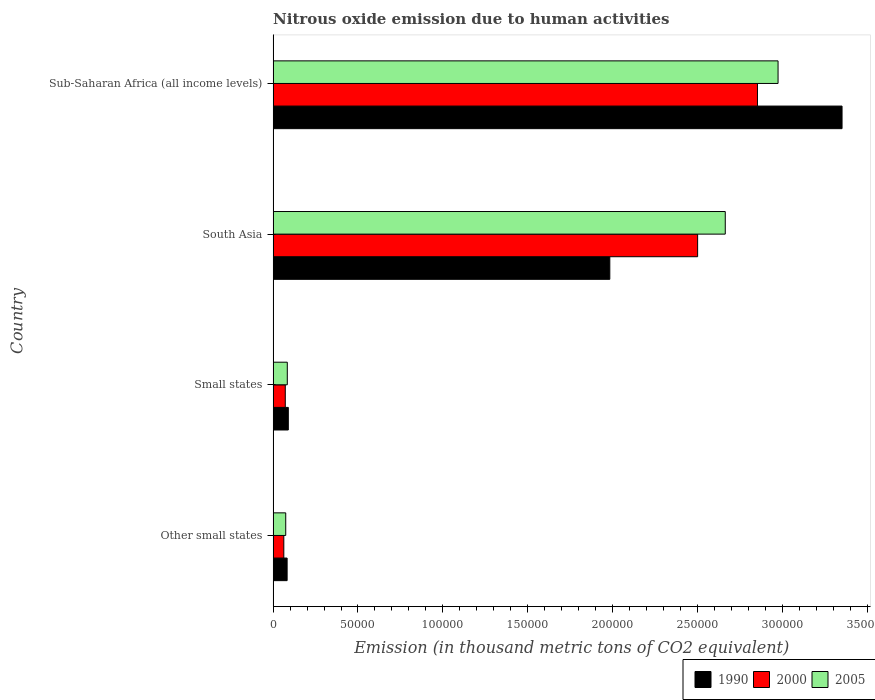How many groups of bars are there?
Offer a terse response. 4. Are the number of bars on each tick of the Y-axis equal?
Provide a succinct answer. Yes. How many bars are there on the 1st tick from the top?
Your answer should be compact. 3. What is the label of the 3rd group of bars from the top?
Offer a very short reply. Small states. What is the amount of nitrous oxide emitted in 1990 in Sub-Saharan Africa (all income levels)?
Give a very brief answer. 3.35e+05. Across all countries, what is the maximum amount of nitrous oxide emitted in 2000?
Give a very brief answer. 2.85e+05. Across all countries, what is the minimum amount of nitrous oxide emitted in 1990?
Provide a succinct answer. 8248.7. In which country was the amount of nitrous oxide emitted in 1990 maximum?
Provide a succinct answer. Sub-Saharan Africa (all income levels). In which country was the amount of nitrous oxide emitted in 2005 minimum?
Your answer should be compact. Other small states. What is the total amount of nitrous oxide emitted in 2000 in the graph?
Make the answer very short. 5.49e+05. What is the difference between the amount of nitrous oxide emitted in 2005 in Small states and that in Sub-Saharan Africa (all income levels)?
Make the answer very short. -2.89e+05. What is the difference between the amount of nitrous oxide emitted in 2005 in Other small states and the amount of nitrous oxide emitted in 1990 in South Asia?
Make the answer very short. -1.91e+05. What is the average amount of nitrous oxide emitted in 2005 per country?
Your answer should be compact. 1.45e+05. What is the difference between the amount of nitrous oxide emitted in 1990 and amount of nitrous oxide emitted in 2000 in Other small states?
Provide a succinct answer. 1951.7. What is the ratio of the amount of nitrous oxide emitted in 2005 in Other small states to that in Sub-Saharan Africa (all income levels)?
Make the answer very short. 0.02. Is the amount of nitrous oxide emitted in 2005 in Other small states less than that in Small states?
Provide a short and direct response. Yes. Is the difference between the amount of nitrous oxide emitted in 1990 in Other small states and South Asia greater than the difference between the amount of nitrous oxide emitted in 2000 in Other small states and South Asia?
Provide a short and direct response. Yes. What is the difference between the highest and the second highest amount of nitrous oxide emitted in 2005?
Provide a short and direct response. 3.11e+04. What is the difference between the highest and the lowest amount of nitrous oxide emitted in 2005?
Give a very brief answer. 2.90e+05. Is the sum of the amount of nitrous oxide emitted in 2000 in South Asia and Sub-Saharan Africa (all income levels) greater than the maximum amount of nitrous oxide emitted in 2005 across all countries?
Offer a very short reply. Yes. What does the 3rd bar from the top in Other small states represents?
Ensure brevity in your answer.  1990. What does the 1st bar from the bottom in Other small states represents?
Offer a very short reply. 1990. How many bars are there?
Your answer should be very brief. 12. How many countries are there in the graph?
Your answer should be very brief. 4. Does the graph contain grids?
Provide a succinct answer. No. How many legend labels are there?
Your answer should be compact. 3. How are the legend labels stacked?
Ensure brevity in your answer.  Horizontal. What is the title of the graph?
Your response must be concise. Nitrous oxide emission due to human activities. Does "1984" appear as one of the legend labels in the graph?
Give a very brief answer. No. What is the label or title of the X-axis?
Your response must be concise. Emission (in thousand metric tons of CO2 equivalent). What is the Emission (in thousand metric tons of CO2 equivalent) in 1990 in Other small states?
Your response must be concise. 8248.7. What is the Emission (in thousand metric tons of CO2 equivalent) in 2000 in Other small states?
Your response must be concise. 6297. What is the Emission (in thousand metric tons of CO2 equivalent) in 2005 in Other small states?
Ensure brevity in your answer.  7434.8. What is the Emission (in thousand metric tons of CO2 equivalent) in 1990 in Small states?
Ensure brevity in your answer.  8947.8. What is the Emission (in thousand metric tons of CO2 equivalent) of 2000 in Small states?
Make the answer very short. 7164.7. What is the Emission (in thousand metric tons of CO2 equivalent) of 2005 in Small states?
Keep it short and to the point. 8358.1. What is the Emission (in thousand metric tons of CO2 equivalent) of 1990 in South Asia?
Offer a terse response. 1.98e+05. What is the Emission (in thousand metric tons of CO2 equivalent) of 2000 in South Asia?
Make the answer very short. 2.50e+05. What is the Emission (in thousand metric tons of CO2 equivalent) of 2005 in South Asia?
Make the answer very short. 2.66e+05. What is the Emission (in thousand metric tons of CO2 equivalent) of 1990 in Sub-Saharan Africa (all income levels)?
Ensure brevity in your answer.  3.35e+05. What is the Emission (in thousand metric tons of CO2 equivalent) in 2000 in Sub-Saharan Africa (all income levels)?
Offer a terse response. 2.85e+05. What is the Emission (in thousand metric tons of CO2 equivalent) in 2005 in Sub-Saharan Africa (all income levels)?
Provide a succinct answer. 2.98e+05. Across all countries, what is the maximum Emission (in thousand metric tons of CO2 equivalent) in 1990?
Provide a short and direct response. 3.35e+05. Across all countries, what is the maximum Emission (in thousand metric tons of CO2 equivalent) of 2000?
Keep it short and to the point. 2.85e+05. Across all countries, what is the maximum Emission (in thousand metric tons of CO2 equivalent) in 2005?
Your answer should be very brief. 2.98e+05. Across all countries, what is the minimum Emission (in thousand metric tons of CO2 equivalent) in 1990?
Provide a succinct answer. 8248.7. Across all countries, what is the minimum Emission (in thousand metric tons of CO2 equivalent) of 2000?
Keep it short and to the point. 6297. Across all countries, what is the minimum Emission (in thousand metric tons of CO2 equivalent) in 2005?
Offer a very short reply. 7434.8. What is the total Emission (in thousand metric tons of CO2 equivalent) of 1990 in the graph?
Offer a terse response. 5.51e+05. What is the total Emission (in thousand metric tons of CO2 equivalent) of 2000 in the graph?
Your answer should be compact. 5.49e+05. What is the total Emission (in thousand metric tons of CO2 equivalent) of 2005 in the graph?
Make the answer very short. 5.80e+05. What is the difference between the Emission (in thousand metric tons of CO2 equivalent) in 1990 in Other small states and that in Small states?
Keep it short and to the point. -699.1. What is the difference between the Emission (in thousand metric tons of CO2 equivalent) in 2000 in Other small states and that in Small states?
Your answer should be very brief. -867.7. What is the difference between the Emission (in thousand metric tons of CO2 equivalent) in 2005 in Other small states and that in Small states?
Keep it short and to the point. -923.3. What is the difference between the Emission (in thousand metric tons of CO2 equivalent) of 1990 in Other small states and that in South Asia?
Give a very brief answer. -1.90e+05. What is the difference between the Emission (in thousand metric tons of CO2 equivalent) in 2000 in Other small states and that in South Asia?
Your answer should be very brief. -2.44e+05. What is the difference between the Emission (in thousand metric tons of CO2 equivalent) in 2005 in Other small states and that in South Asia?
Keep it short and to the point. -2.59e+05. What is the difference between the Emission (in thousand metric tons of CO2 equivalent) of 1990 in Other small states and that in Sub-Saharan Africa (all income levels)?
Your response must be concise. -3.27e+05. What is the difference between the Emission (in thousand metric tons of CO2 equivalent) of 2000 in Other small states and that in Sub-Saharan Africa (all income levels)?
Provide a short and direct response. -2.79e+05. What is the difference between the Emission (in thousand metric tons of CO2 equivalent) in 2005 in Other small states and that in Sub-Saharan Africa (all income levels)?
Your response must be concise. -2.90e+05. What is the difference between the Emission (in thousand metric tons of CO2 equivalent) of 1990 in Small states and that in South Asia?
Provide a short and direct response. -1.89e+05. What is the difference between the Emission (in thousand metric tons of CO2 equivalent) in 2000 in Small states and that in South Asia?
Provide a succinct answer. -2.43e+05. What is the difference between the Emission (in thousand metric tons of CO2 equivalent) in 2005 in Small states and that in South Asia?
Your answer should be very brief. -2.58e+05. What is the difference between the Emission (in thousand metric tons of CO2 equivalent) in 1990 in Small states and that in Sub-Saharan Africa (all income levels)?
Provide a short and direct response. -3.26e+05. What is the difference between the Emission (in thousand metric tons of CO2 equivalent) of 2000 in Small states and that in Sub-Saharan Africa (all income levels)?
Your answer should be very brief. -2.78e+05. What is the difference between the Emission (in thousand metric tons of CO2 equivalent) of 2005 in Small states and that in Sub-Saharan Africa (all income levels)?
Your response must be concise. -2.89e+05. What is the difference between the Emission (in thousand metric tons of CO2 equivalent) of 1990 in South Asia and that in Sub-Saharan Africa (all income levels)?
Offer a very short reply. -1.37e+05. What is the difference between the Emission (in thousand metric tons of CO2 equivalent) of 2000 in South Asia and that in Sub-Saharan Africa (all income levels)?
Your answer should be compact. -3.53e+04. What is the difference between the Emission (in thousand metric tons of CO2 equivalent) of 2005 in South Asia and that in Sub-Saharan Africa (all income levels)?
Keep it short and to the point. -3.11e+04. What is the difference between the Emission (in thousand metric tons of CO2 equivalent) in 1990 in Other small states and the Emission (in thousand metric tons of CO2 equivalent) in 2000 in Small states?
Offer a very short reply. 1084. What is the difference between the Emission (in thousand metric tons of CO2 equivalent) of 1990 in Other small states and the Emission (in thousand metric tons of CO2 equivalent) of 2005 in Small states?
Provide a succinct answer. -109.4. What is the difference between the Emission (in thousand metric tons of CO2 equivalent) of 2000 in Other small states and the Emission (in thousand metric tons of CO2 equivalent) of 2005 in Small states?
Provide a succinct answer. -2061.1. What is the difference between the Emission (in thousand metric tons of CO2 equivalent) of 1990 in Other small states and the Emission (in thousand metric tons of CO2 equivalent) of 2000 in South Asia?
Offer a very short reply. -2.42e+05. What is the difference between the Emission (in thousand metric tons of CO2 equivalent) in 1990 in Other small states and the Emission (in thousand metric tons of CO2 equivalent) in 2005 in South Asia?
Keep it short and to the point. -2.58e+05. What is the difference between the Emission (in thousand metric tons of CO2 equivalent) in 2000 in Other small states and the Emission (in thousand metric tons of CO2 equivalent) in 2005 in South Asia?
Keep it short and to the point. -2.60e+05. What is the difference between the Emission (in thousand metric tons of CO2 equivalent) in 1990 in Other small states and the Emission (in thousand metric tons of CO2 equivalent) in 2000 in Sub-Saharan Africa (all income levels)?
Provide a short and direct response. -2.77e+05. What is the difference between the Emission (in thousand metric tons of CO2 equivalent) of 1990 in Other small states and the Emission (in thousand metric tons of CO2 equivalent) of 2005 in Sub-Saharan Africa (all income levels)?
Your answer should be very brief. -2.89e+05. What is the difference between the Emission (in thousand metric tons of CO2 equivalent) in 2000 in Other small states and the Emission (in thousand metric tons of CO2 equivalent) in 2005 in Sub-Saharan Africa (all income levels)?
Your response must be concise. -2.91e+05. What is the difference between the Emission (in thousand metric tons of CO2 equivalent) in 1990 in Small states and the Emission (in thousand metric tons of CO2 equivalent) in 2000 in South Asia?
Offer a terse response. -2.41e+05. What is the difference between the Emission (in thousand metric tons of CO2 equivalent) of 1990 in Small states and the Emission (in thousand metric tons of CO2 equivalent) of 2005 in South Asia?
Give a very brief answer. -2.57e+05. What is the difference between the Emission (in thousand metric tons of CO2 equivalent) of 2000 in Small states and the Emission (in thousand metric tons of CO2 equivalent) of 2005 in South Asia?
Offer a terse response. -2.59e+05. What is the difference between the Emission (in thousand metric tons of CO2 equivalent) in 1990 in Small states and the Emission (in thousand metric tons of CO2 equivalent) in 2000 in Sub-Saharan Africa (all income levels)?
Ensure brevity in your answer.  -2.76e+05. What is the difference between the Emission (in thousand metric tons of CO2 equivalent) of 1990 in Small states and the Emission (in thousand metric tons of CO2 equivalent) of 2005 in Sub-Saharan Africa (all income levels)?
Keep it short and to the point. -2.89e+05. What is the difference between the Emission (in thousand metric tons of CO2 equivalent) in 2000 in Small states and the Emission (in thousand metric tons of CO2 equivalent) in 2005 in Sub-Saharan Africa (all income levels)?
Your answer should be very brief. -2.90e+05. What is the difference between the Emission (in thousand metric tons of CO2 equivalent) in 1990 in South Asia and the Emission (in thousand metric tons of CO2 equivalent) in 2000 in Sub-Saharan Africa (all income levels)?
Your answer should be very brief. -8.70e+04. What is the difference between the Emission (in thousand metric tons of CO2 equivalent) of 1990 in South Asia and the Emission (in thousand metric tons of CO2 equivalent) of 2005 in Sub-Saharan Africa (all income levels)?
Your answer should be very brief. -9.91e+04. What is the difference between the Emission (in thousand metric tons of CO2 equivalent) of 2000 in South Asia and the Emission (in thousand metric tons of CO2 equivalent) of 2005 in Sub-Saharan Africa (all income levels)?
Give a very brief answer. -4.74e+04. What is the average Emission (in thousand metric tons of CO2 equivalent) in 1990 per country?
Your answer should be compact. 1.38e+05. What is the average Emission (in thousand metric tons of CO2 equivalent) in 2000 per country?
Make the answer very short. 1.37e+05. What is the average Emission (in thousand metric tons of CO2 equivalent) of 2005 per country?
Offer a very short reply. 1.45e+05. What is the difference between the Emission (in thousand metric tons of CO2 equivalent) in 1990 and Emission (in thousand metric tons of CO2 equivalent) in 2000 in Other small states?
Ensure brevity in your answer.  1951.7. What is the difference between the Emission (in thousand metric tons of CO2 equivalent) of 1990 and Emission (in thousand metric tons of CO2 equivalent) of 2005 in Other small states?
Make the answer very short. 813.9. What is the difference between the Emission (in thousand metric tons of CO2 equivalent) of 2000 and Emission (in thousand metric tons of CO2 equivalent) of 2005 in Other small states?
Offer a very short reply. -1137.8. What is the difference between the Emission (in thousand metric tons of CO2 equivalent) of 1990 and Emission (in thousand metric tons of CO2 equivalent) of 2000 in Small states?
Make the answer very short. 1783.1. What is the difference between the Emission (in thousand metric tons of CO2 equivalent) in 1990 and Emission (in thousand metric tons of CO2 equivalent) in 2005 in Small states?
Provide a short and direct response. 589.7. What is the difference between the Emission (in thousand metric tons of CO2 equivalent) in 2000 and Emission (in thousand metric tons of CO2 equivalent) in 2005 in Small states?
Offer a very short reply. -1193.4. What is the difference between the Emission (in thousand metric tons of CO2 equivalent) in 1990 and Emission (in thousand metric tons of CO2 equivalent) in 2000 in South Asia?
Offer a terse response. -5.17e+04. What is the difference between the Emission (in thousand metric tons of CO2 equivalent) of 1990 and Emission (in thousand metric tons of CO2 equivalent) of 2005 in South Asia?
Make the answer very short. -6.80e+04. What is the difference between the Emission (in thousand metric tons of CO2 equivalent) in 2000 and Emission (in thousand metric tons of CO2 equivalent) in 2005 in South Asia?
Make the answer very short. -1.63e+04. What is the difference between the Emission (in thousand metric tons of CO2 equivalent) of 1990 and Emission (in thousand metric tons of CO2 equivalent) of 2000 in Sub-Saharan Africa (all income levels)?
Provide a succinct answer. 4.98e+04. What is the difference between the Emission (in thousand metric tons of CO2 equivalent) of 1990 and Emission (in thousand metric tons of CO2 equivalent) of 2005 in Sub-Saharan Africa (all income levels)?
Keep it short and to the point. 3.77e+04. What is the difference between the Emission (in thousand metric tons of CO2 equivalent) of 2000 and Emission (in thousand metric tons of CO2 equivalent) of 2005 in Sub-Saharan Africa (all income levels)?
Keep it short and to the point. -1.21e+04. What is the ratio of the Emission (in thousand metric tons of CO2 equivalent) in 1990 in Other small states to that in Small states?
Keep it short and to the point. 0.92. What is the ratio of the Emission (in thousand metric tons of CO2 equivalent) in 2000 in Other small states to that in Small states?
Offer a terse response. 0.88. What is the ratio of the Emission (in thousand metric tons of CO2 equivalent) of 2005 in Other small states to that in Small states?
Your response must be concise. 0.89. What is the ratio of the Emission (in thousand metric tons of CO2 equivalent) of 1990 in Other small states to that in South Asia?
Give a very brief answer. 0.04. What is the ratio of the Emission (in thousand metric tons of CO2 equivalent) in 2000 in Other small states to that in South Asia?
Your answer should be compact. 0.03. What is the ratio of the Emission (in thousand metric tons of CO2 equivalent) of 2005 in Other small states to that in South Asia?
Keep it short and to the point. 0.03. What is the ratio of the Emission (in thousand metric tons of CO2 equivalent) in 1990 in Other small states to that in Sub-Saharan Africa (all income levels)?
Your response must be concise. 0.02. What is the ratio of the Emission (in thousand metric tons of CO2 equivalent) of 2000 in Other small states to that in Sub-Saharan Africa (all income levels)?
Your answer should be very brief. 0.02. What is the ratio of the Emission (in thousand metric tons of CO2 equivalent) in 2005 in Other small states to that in Sub-Saharan Africa (all income levels)?
Your answer should be very brief. 0.03. What is the ratio of the Emission (in thousand metric tons of CO2 equivalent) of 1990 in Small states to that in South Asia?
Your response must be concise. 0.05. What is the ratio of the Emission (in thousand metric tons of CO2 equivalent) of 2000 in Small states to that in South Asia?
Give a very brief answer. 0.03. What is the ratio of the Emission (in thousand metric tons of CO2 equivalent) of 2005 in Small states to that in South Asia?
Provide a short and direct response. 0.03. What is the ratio of the Emission (in thousand metric tons of CO2 equivalent) in 1990 in Small states to that in Sub-Saharan Africa (all income levels)?
Offer a very short reply. 0.03. What is the ratio of the Emission (in thousand metric tons of CO2 equivalent) in 2000 in Small states to that in Sub-Saharan Africa (all income levels)?
Give a very brief answer. 0.03. What is the ratio of the Emission (in thousand metric tons of CO2 equivalent) in 2005 in Small states to that in Sub-Saharan Africa (all income levels)?
Give a very brief answer. 0.03. What is the ratio of the Emission (in thousand metric tons of CO2 equivalent) of 1990 in South Asia to that in Sub-Saharan Africa (all income levels)?
Your answer should be very brief. 0.59. What is the ratio of the Emission (in thousand metric tons of CO2 equivalent) in 2000 in South Asia to that in Sub-Saharan Africa (all income levels)?
Your response must be concise. 0.88. What is the ratio of the Emission (in thousand metric tons of CO2 equivalent) in 2005 in South Asia to that in Sub-Saharan Africa (all income levels)?
Your response must be concise. 0.9. What is the difference between the highest and the second highest Emission (in thousand metric tons of CO2 equivalent) of 1990?
Keep it short and to the point. 1.37e+05. What is the difference between the highest and the second highest Emission (in thousand metric tons of CO2 equivalent) in 2000?
Ensure brevity in your answer.  3.53e+04. What is the difference between the highest and the second highest Emission (in thousand metric tons of CO2 equivalent) in 2005?
Make the answer very short. 3.11e+04. What is the difference between the highest and the lowest Emission (in thousand metric tons of CO2 equivalent) in 1990?
Give a very brief answer. 3.27e+05. What is the difference between the highest and the lowest Emission (in thousand metric tons of CO2 equivalent) in 2000?
Give a very brief answer. 2.79e+05. What is the difference between the highest and the lowest Emission (in thousand metric tons of CO2 equivalent) in 2005?
Provide a short and direct response. 2.90e+05. 